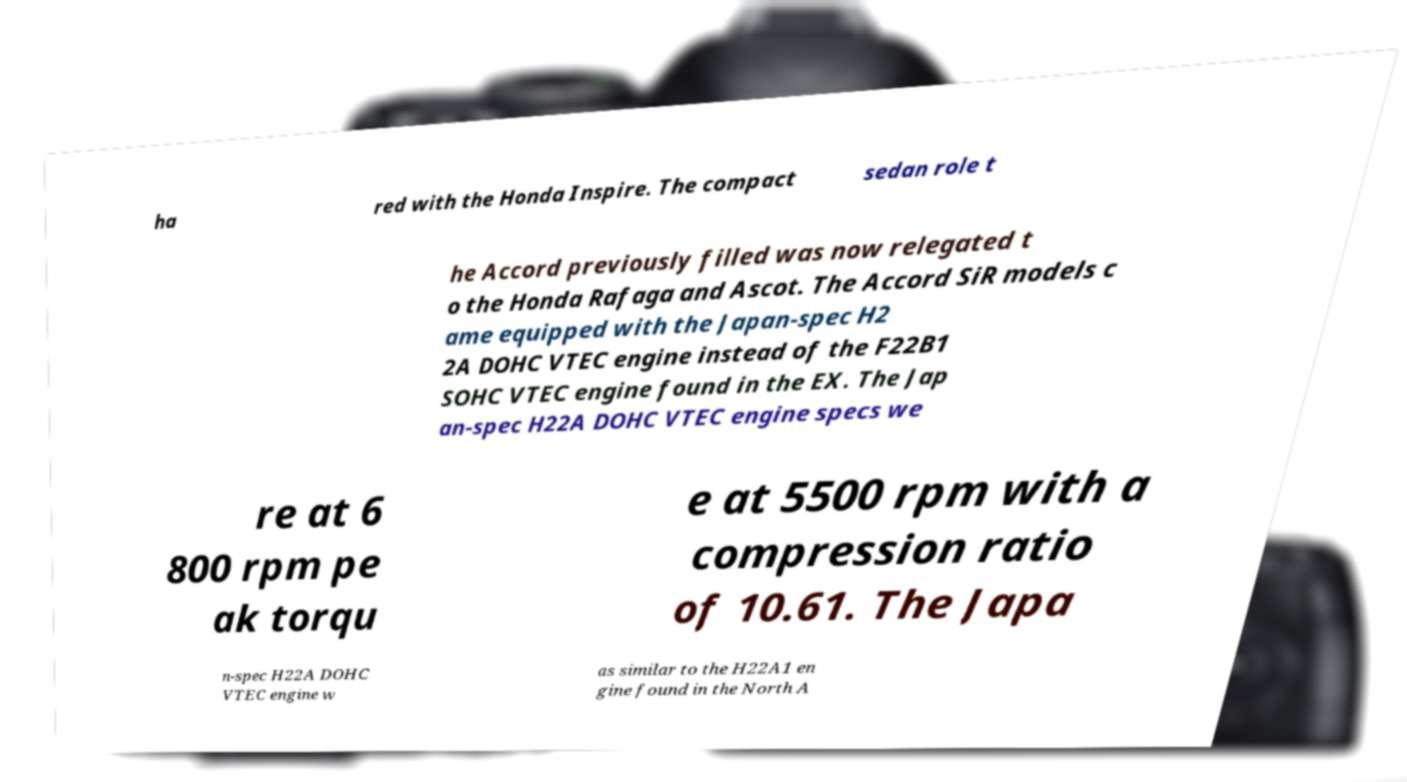Could you assist in decoding the text presented in this image and type it out clearly? ha red with the Honda Inspire. The compact sedan role t he Accord previously filled was now relegated t o the Honda Rafaga and Ascot. The Accord SiR models c ame equipped with the Japan-spec H2 2A DOHC VTEC engine instead of the F22B1 SOHC VTEC engine found in the EX. The Jap an-spec H22A DOHC VTEC engine specs we re at 6 800 rpm pe ak torqu e at 5500 rpm with a compression ratio of 10.61. The Japa n-spec H22A DOHC VTEC engine w as similar to the H22A1 en gine found in the North A 